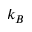<formula> <loc_0><loc_0><loc_500><loc_500>k _ { B }</formula> 